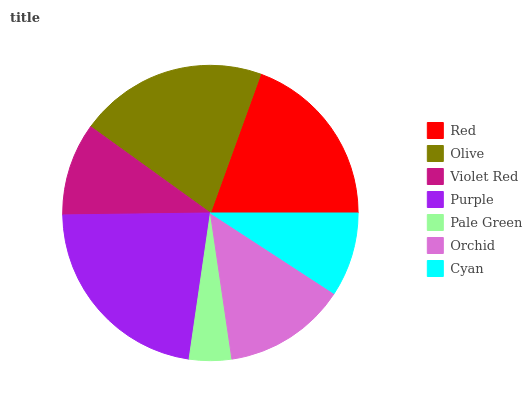Is Pale Green the minimum?
Answer yes or no. Yes. Is Purple the maximum?
Answer yes or no. Yes. Is Olive the minimum?
Answer yes or no. No. Is Olive the maximum?
Answer yes or no. No. Is Olive greater than Red?
Answer yes or no. Yes. Is Red less than Olive?
Answer yes or no. Yes. Is Red greater than Olive?
Answer yes or no. No. Is Olive less than Red?
Answer yes or no. No. Is Orchid the high median?
Answer yes or no. Yes. Is Orchid the low median?
Answer yes or no. Yes. Is Red the high median?
Answer yes or no. No. Is Violet Red the low median?
Answer yes or no. No. 